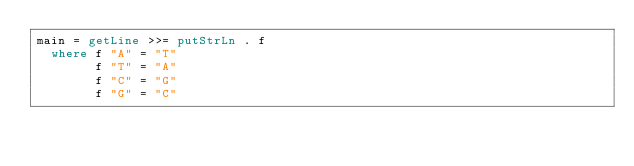Convert code to text. <code><loc_0><loc_0><loc_500><loc_500><_Haskell_>main = getLine >>= putStrLn . f
  where f "A" = "T"
        f "T" = "A"
        f "C" = "G"
        f "G" = "C"
</code> 